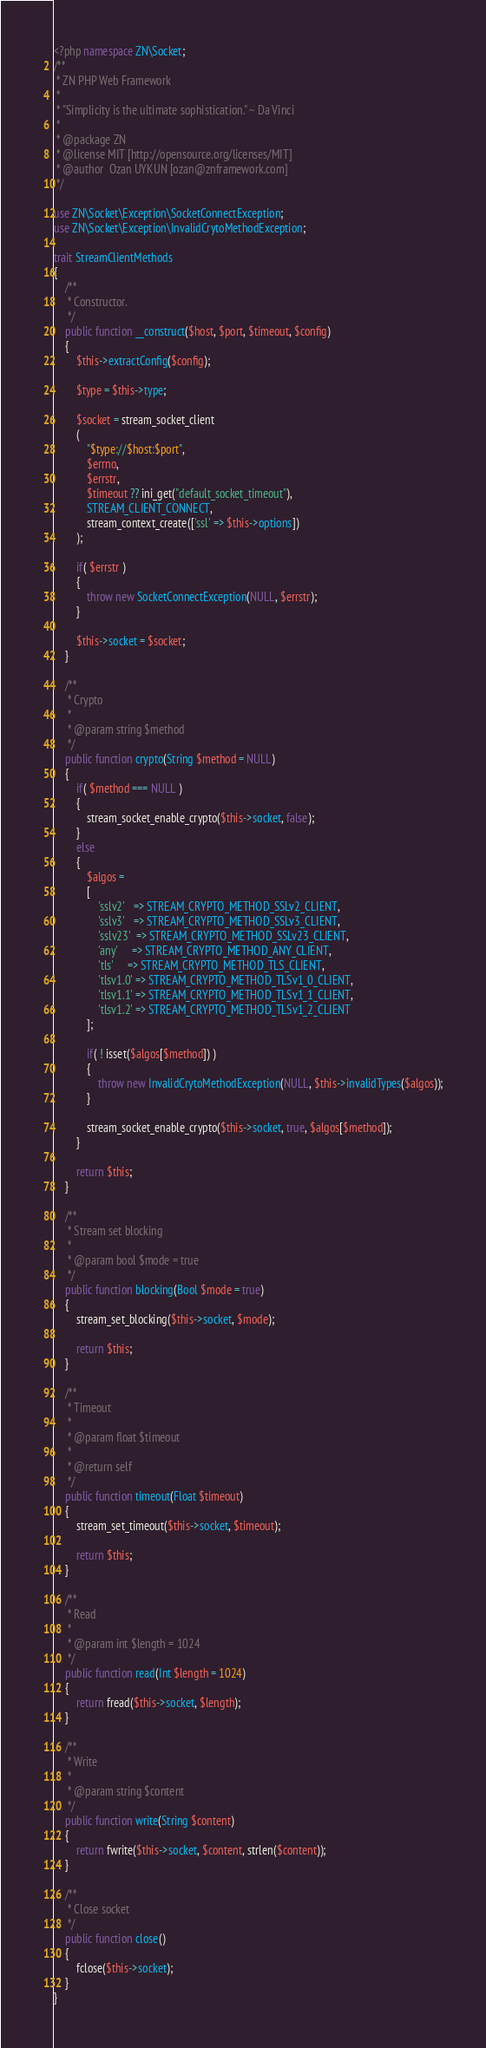<code> <loc_0><loc_0><loc_500><loc_500><_PHP_><?php namespace ZN\Socket;
/**
 * ZN PHP Web Framework
 * 
 * "Simplicity is the ultimate sophistication." ~ Da Vinci
 * 
 * @package ZN
 * @license MIT [http://opensource.org/licenses/MIT]
 * @author  Ozan UYKUN [ozan@znframework.com]
 */

use ZN\Socket\Exception\SocketConnectException;
use ZN\Socket\Exception\InvalidCrytoMethodException;

trait StreamClientMethods
{   
    /**
     * Constructor.
     */
    public function __construct($host, $port, $timeout, $config)
    {
        $this->extractConfig($config);

        $type = $this->type;

        $socket = stream_socket_client
        (
            "$type://$host:$port", 
            $errno, 
            $errstr, 
            $timeout ?? ini_get("default_socket_timeout"),
            STREAM_CLIENT_CONNECT,
            stream_context_create(['ssl' => $this->options])
        );

        if( $errstr )
        {
            throw new SocketConnectException(NULL, $errstr);
        }

        $this->socket = $socket;
    }

    /**
     * Crypto
     * 
     * @param string $method
     */
    public function crypto(String $method = NULL)
    {
        if( $method === NULL )
        {
            stream_socket_enable_crypto($this->socket, false);
        }
        else
        {
            $algos = 
            [
                'sslv2'   => STREAM_CRYPTO_METHOD_SSLv2_CLIENT,
                'sslv3'   => STREAM_CRYPTO_METHOD_SSLv3_CLIENT,
                'sslv23'  => STREAM_CRYPTO_METHOD_SSLv23_CLIENT,
                'any'     => STREAM_CRYPTO_METHOD_ANY_CLIENT,
                'tls'     => STREAM_CRYPTO_METHOD_TLS_CLIENT,
                'tlsv1.0' => STREAM_CRYPTO_METHOD_TLSv1_0_CLIENT,
                'tlsv1.1' => STREAM_CRYPTO_METHOD_TLSv1_1_CLIENT,
                'tlsv1.2' => STREAM_CRYPTO_METHOD_TLSv1_2_CLIENT
            ];

            if( ! isset($algos[$method]) )
            {
                throw new InvalidCrytoMethodException(NULL, $this->invalidTypes($algos));
            }
            
            stream_socket_enable_crypto($this->socket, true, $algos[$method]);
        }

        return $this;
    }

    /**
     * Stream set blocking
     * 
     * @param bool $mode = true
     */
    public function blocking(Bool $mode = true)
    {
        stream_set_blocking($this->socket, $mode);

        return $this;
    }

    /**
     * Timeout
     * 
     * @param float $timeout
     * 
     * @return self
     */
    public function timeout(Float $timeout)
    {
        stream_set_timeout($this->socket, $timeout);

        return $this;
    }

    /**
     * Read
     * 
     * @param int $length = 1024
     */
    public function read(Int $length = 1024)
    {
        return fread($this->socket, $length);
    }

    /**
     * Write
     * 
     * @param string $content
     */
    public function write(String $content)
    {
        return fwrite($this->socket, $content, strlen($content));
    }

    /**
     * Close socket
     */
    public function close()
    {
        fclose($this->socket);
    }
}</code> 